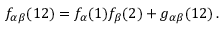<formula> <loc_0><loc_0><loc_500><loc_500>f _ { \alpha \beta } ( 1 2 ) = f _ { \alpha } ( 1 ) f _ { \beta } ( 2 ) + g _ { \alpha \beta } ( 1 2 ) \, .</formula> 